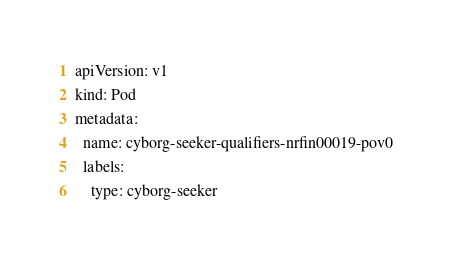<code> <loc_0><loc_0><loc_500><loc_500><_YAML_>apiVersion: v1
kind: Pod
metadata:
  name: cyborg-seeker-qualifiers-nrfin00019-pov0
  labels:
    type: cyborg-seeker</code> 